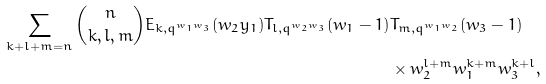Convert formula to latex. <formula><loc_0><loc_0><loc_500><loc_500>\sum _ { k + l + m = n } \binom { n } { k , l , m } E _ { k , q ^ { w _ { 1 } w _ { 3 } } } ( w _ { 2 } y _ { 1 } ) T _ { l , q ^ { w _ { 2 } w _ { 3 } } } ( w _ { 1 } - 1 ) & T _ { m , q ^ { w _ { 1 } w _ { 2 } } } ( w _ { 3 } - 1 ) \\ & \times w _ { 2 } ^ { l + m } w _ { 1 } ^ { k + m } w _ { 3 } ^ { k + l } ,</formula> 